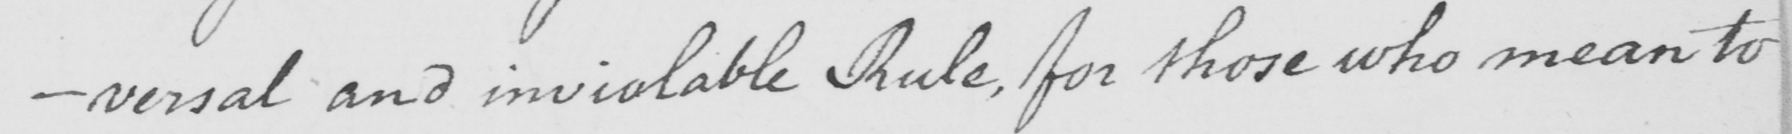Transcribe the text shown in this historical manuscript line. -versal and inviolable Rule , for those who mean to 